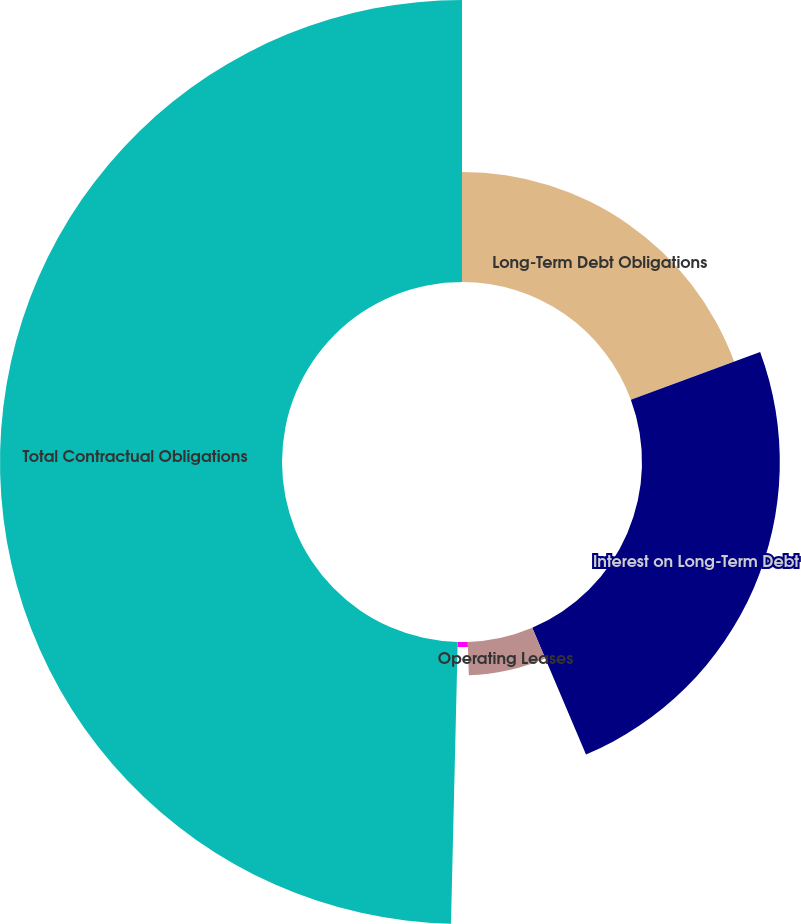<chart> <loc_0><loc_0><loc_500><loc_500><pie_chart><fcel>Long-Term Debt Obligations<fcel>Interest on Long-Term Debt<fcel>Operating Leases<fcel>Financing Leases<fcel>Total Contractual Obligations<nl><fcel>19.37%<fcel>24.25%<fcel>5.87%<fcel>0.89%<fcel>49.62%<nl></chart> 